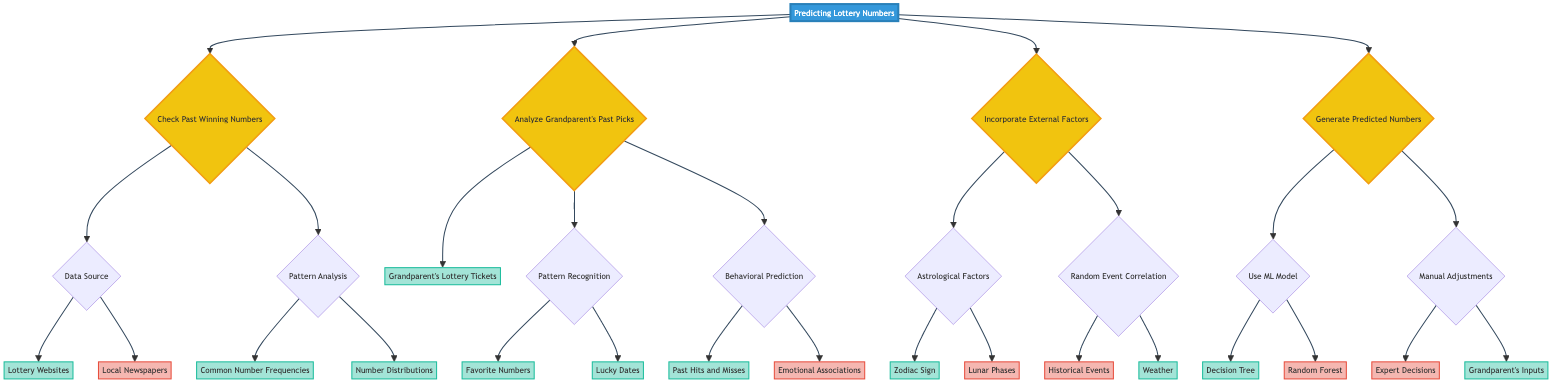What are the sources used to check past winning numbers? The diagram indicates that the sources for checking past winning numbers are "Lottery Websites" and "Local Newspapers." It specifies that "Local Newspapers" is marked as "No," indicating it's not used, while "Lottery Websites" is marked as "Yes."
Answer: Lottery Websites How many methods are included in generating predicted numbers? The diagram shows two primary methods for generating predicted numbers: "Use ML Model" and "Manual Adjustments." Each of these methods has its branches, but the question specifically focuses on the main categories, which is two.
Answer: Two What type of model is used for the machine learning approach? The diagram specifies that under "Use ML Model," the selected approach is "Decision Tree." "Random Forest" is marked as "No," indicating it is not used in this case.
Answer: Decision Tree Are emotional associations considered in behavioral prediction? The diagram indicates that "Emotional Associations" is categorized under "Behavioral Prediction" and is marked as "No," meaning it is not considered in this specific analysis.
Answer: No What external factor related to weather is incorporated? The diagram shows that under "Random Event Correlation," "Weather" is marked as "Yes," indicating that weather is considered an external factor in the prediction process.
Answer: Weather How is the grandparent's input used in the prediction model? The diagram under "Manual Adjustments" indicates that "Grandparent's Inputs" is marked as "Yes." This shows that feedback or preferences from the grandparent are taken into account when generating the predicted numbers.
Answer: Yes How many branches does "Pattern Recognition" have? "Pattern Recognition" branches out into two aspects: "Favorite Numbers" and "Lucky Dates." Both are distinct branches stemming from the "Pattern Recognition" node. Thus, it has two branches.
Answer: Two What kind of data sources are analyzed for the grandparent's past picks? The diagram clearly states that the primary data source analyzed is "Grandparent's Lottery Tickets," which is marked as "Yes," confirming its inclusion in the analysis.
Answer: Grandparent's Lottery Tickets Which astrological factor is included in the analysis? The diagram indicates "Zodiac Sign" as included under "Astrological Factors," which is marked as "Yes." In contrast, "Lunar Phases" is marked as "No," meaning it is not included.
Answer: Zodiac Sign 